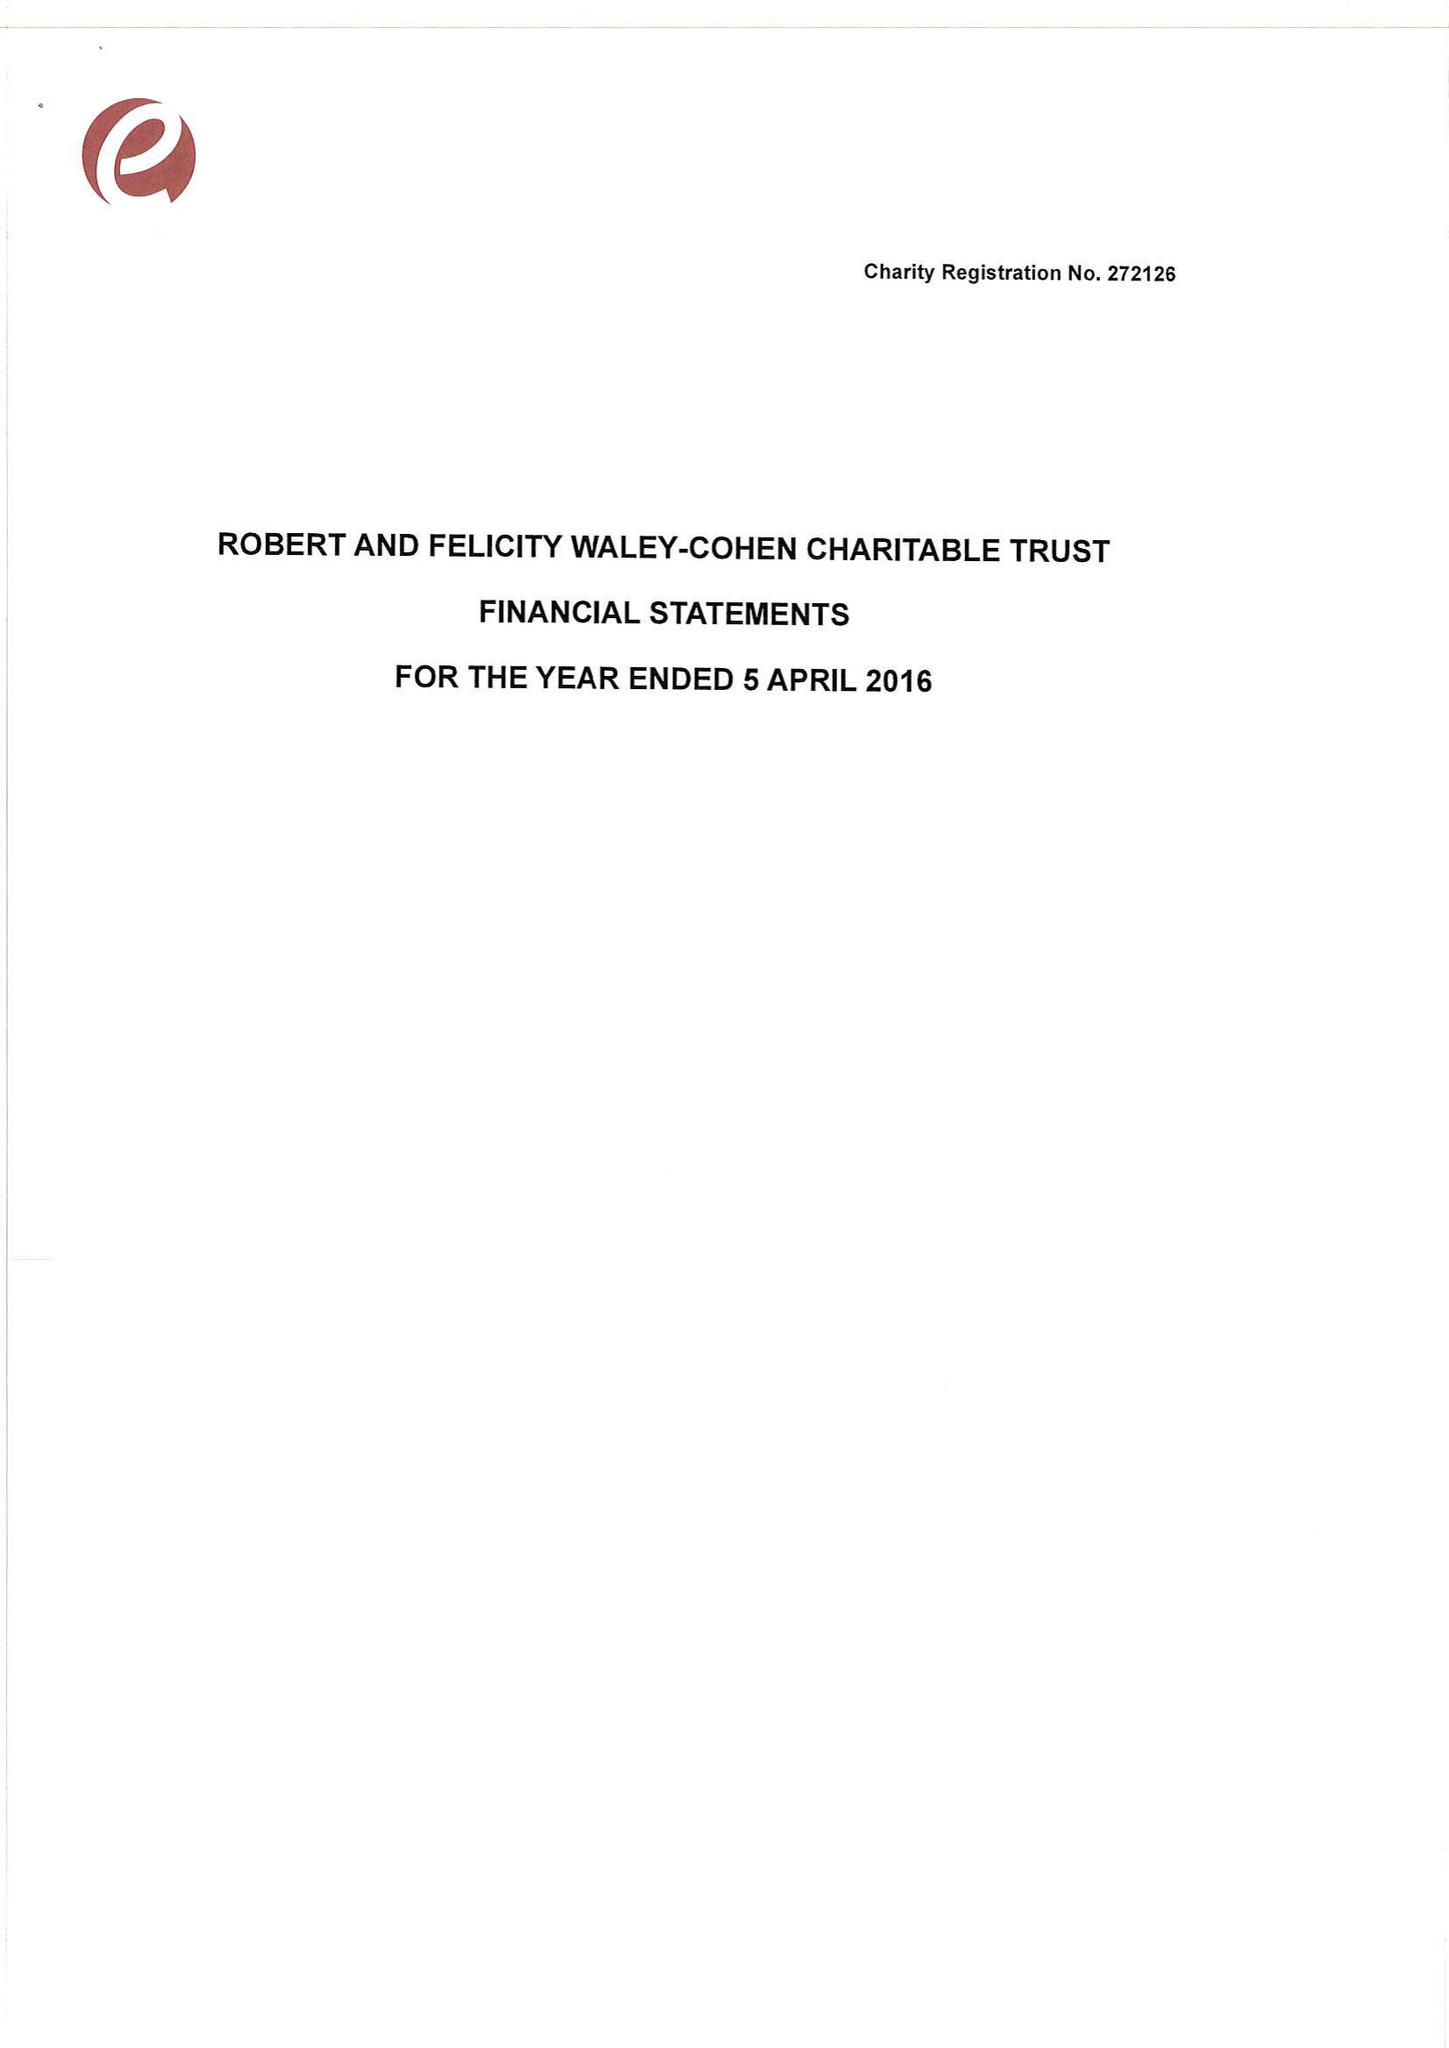What is the value for the income_annually_in_british_pounds?
Answer the question using a single word or phrase. 144962.00 